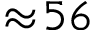Convert formula to latex. <formula><loc_0><loc_0><loc_500><loc_500>\approx \, 5 6</formula> 